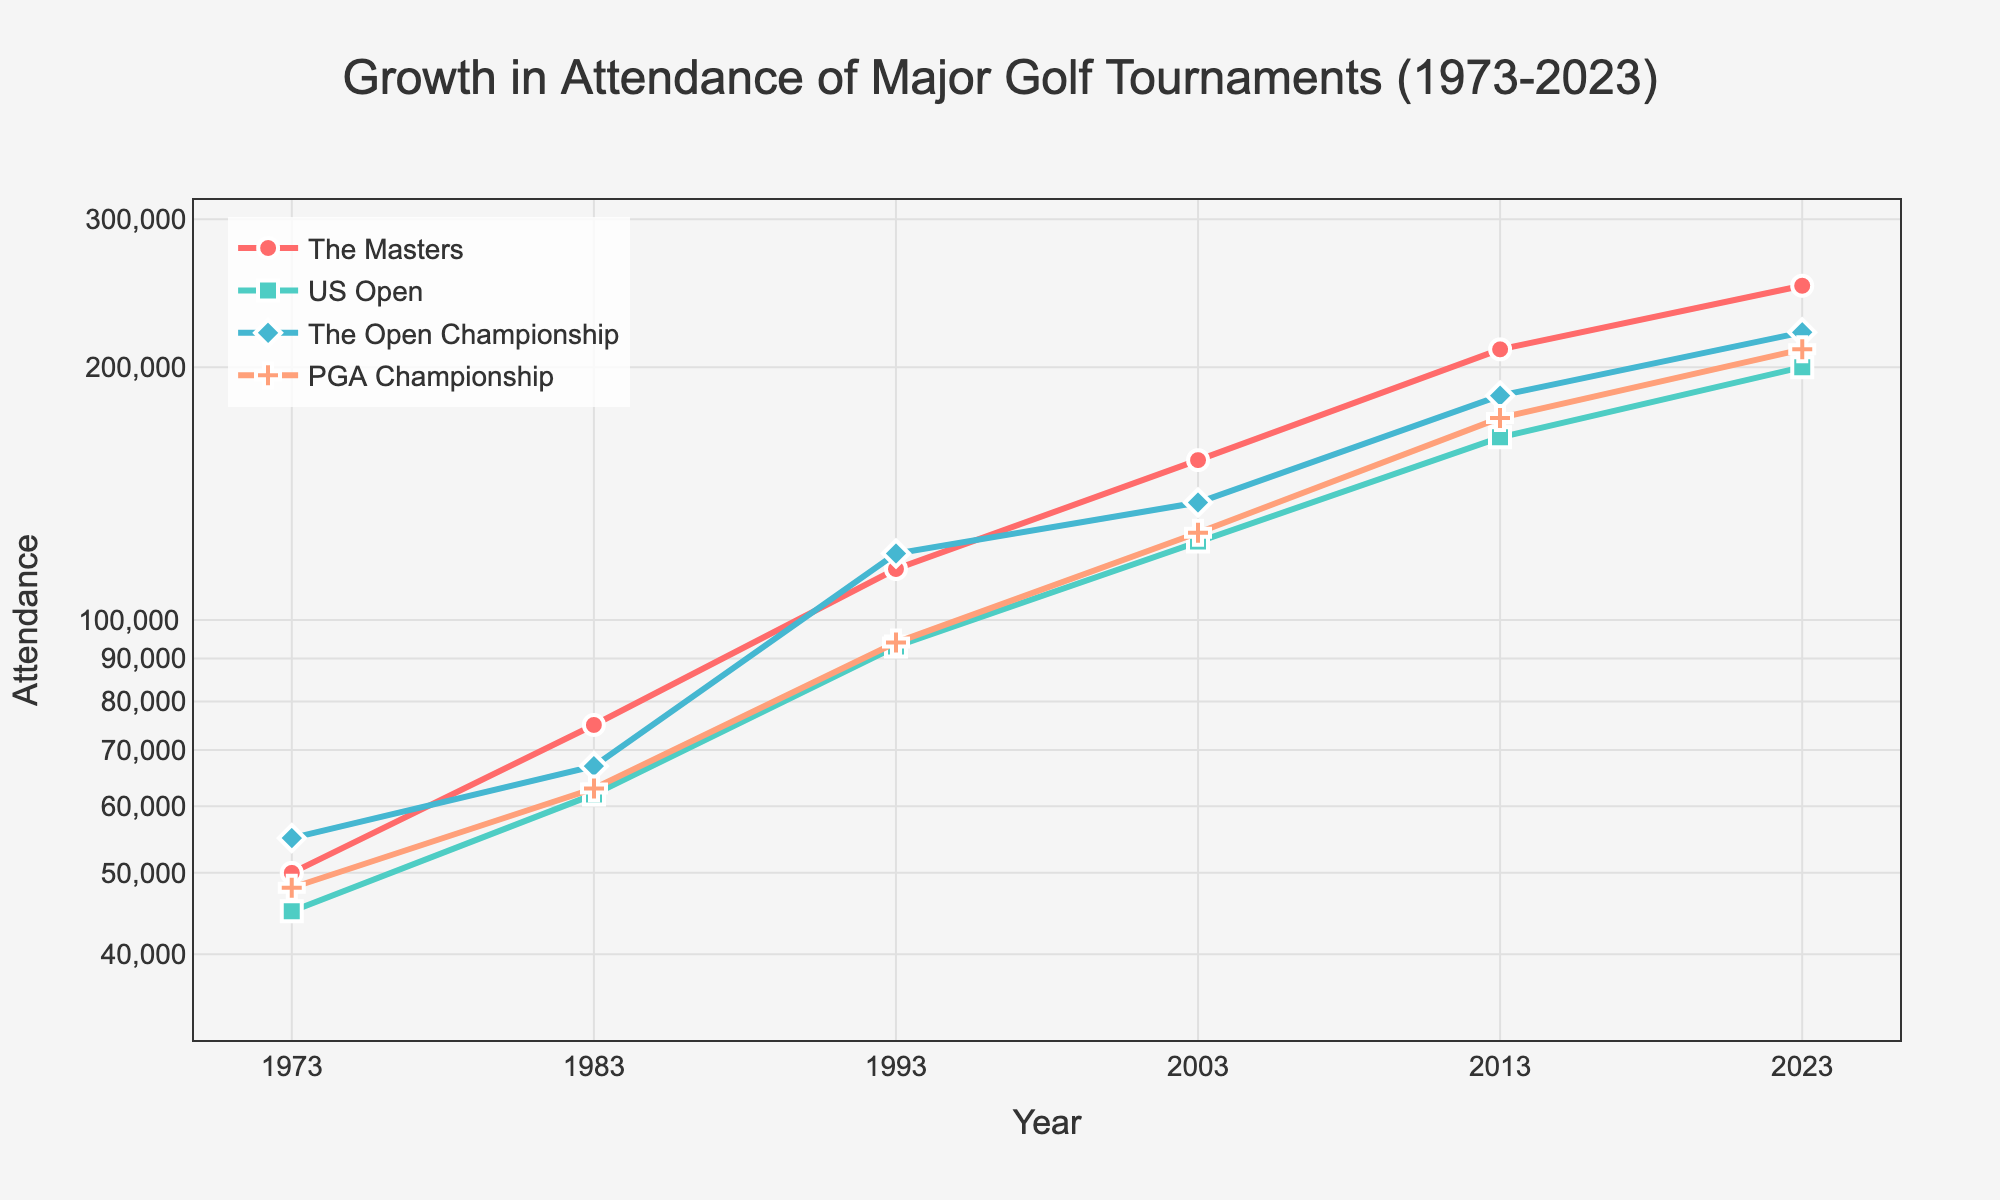When did The Masters tournament first reach an attendance of 210,000? Look at the plot for The Masters line (usually indicated by its color and marker) and check the year when the attendance reaches 210,000.
Answer: 2013 Which tournament had the largest increase in attendance from 1973 to 2023? Calculate the difference in attendance from 1973 to 2023 for each tournament and compare the values. The tournament with the largest difference is the answer.
Answer: The Masters What is the attendance difference between the US Open and the PGA Championship in 2003? Find the attendance values for both tournaments in 2003 (US Open: 124,000 and PGA Championship: 127,000) and subtract the smaller value from the larger one.
Answer: 3,000 Which tournament showed the most consistent growth over the 50 years based on the straightest line in the plot? Visually inspect the lines and identify which one appears the straightest, indicating consistent year-over-year growth.
Answer: The Open Championship How many years did it take for The Open Championship to double its attendance from 1973 to 1993? Find the attendance of The Open Championship in 1973 and 1993, then see if the 1993 value is close to double the 1973 value and count the years between these two dates.
Answer: 20 years What is the overall trend in attendance for all major golf tournaments from 1973 to 2023? Observe the lines over the 50-year span to determine the general direction of change for all tournaments' attendances.
Answer: Increasing Which tournament had the smallest attendance in 1983? Look at the attendance values for all four tournaments in the year 1983 and identify the smallest value.
Answer: US Open How does the growth rate of the PGA Championship compare to The Masters between 1973 and 2023? Calculate the growth rates by finding the ratios of the final to initial attendance for the two tournaments over the 50-year span and compare these ratios.
Answer: The Masters had a higher growth rate What was the attendance for The Open Championship in 2013? Locate the point on the line for The Open Championship in 2013 and note the attendance value.
Answer: 185,000 Which tournament had the highest attendance in 2023? Look at the final data points for each tournament on the plot in the year 2023 and identify the highest point.
Answer: The Masters 